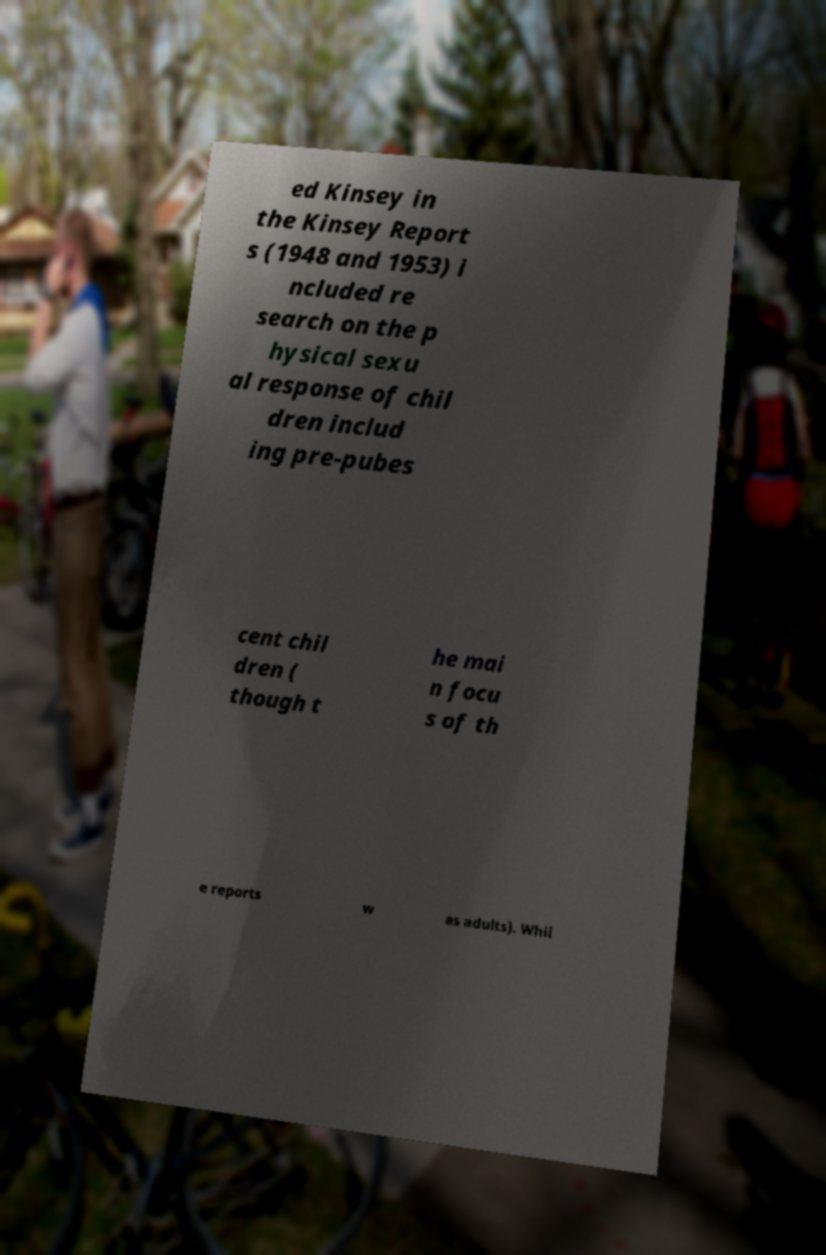Can you accurately transcribe the text from the provided image for me? ed Kinsey in the Kinsey Report s (1948 and 1953) i ncluded re search on the p hysical sexu al response of chil dren includ ing pre-pubes cent chil dren ( though t he mai n focu s of th e reports w as adults). Whil 